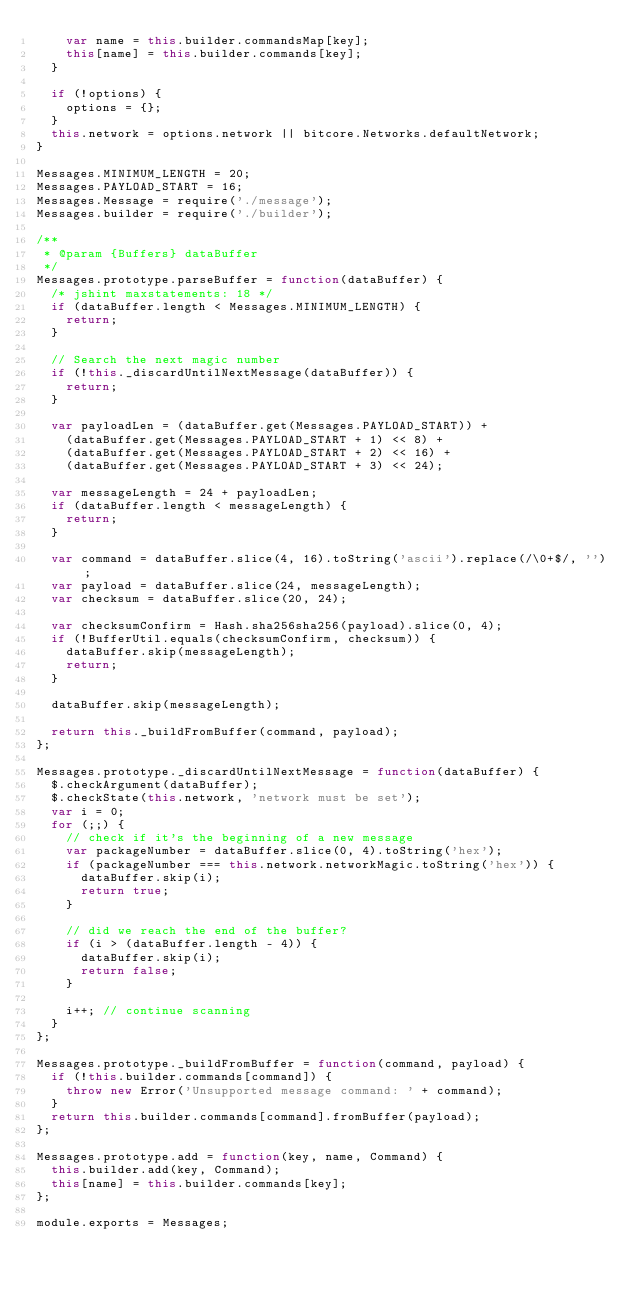Convert code to text. <code><loc_0><loc_0><loc_500><loc_500><_JavaScript_>    var name = this.builder.commandsMap[key];
    this[name] = this.builder.commands[key];
  }

  if (!options) {
    options = {};
  }
  this.network = options.network || bitcore.Networks.defaultNetwork;
}

Messages.MINIMUM_LENGTH = 20;
Messages.PAYLOAD_START = 16;
Messages.Message = require('./message');
Messages.builder = require('./builder');

/**
 * @param {Buffers} dataBuffer
 */
Messages.prototype.parseBuffer = function(dataBuffer) {
  /* jshint maxstatements: 18 */
  if (dataBuffer.length < Messages.MINIMUM_LENGTH) {
    return;
  }

  // Search the next magic number
  if (!this._discardUntilNextMessage(dataBuffer)) {
    return;
  }

  var payloadLen = (dataBuffer.get(Messages.PAYLOAD_START)) +
    (dataBuffer.get(Messages.PAYLOAD_START + 1) << 8) +
    (dataBuffer.get(Messages.PAYLOAD_START + 2) << 16) +
    (dataBuffer.get(Messages.PAYLOAD_START + 3) << 24);

  var messageLength = 24 + payloadLen;
  if (dataBuffer.length < messageLength) {
    return;
  }

  var command = dataBuffer.slice(4, 16).toString('ascii').replace(/\0+$/, '');
  var payload = dataBuffer.slice(24, messageLength);
  var checksum = dataBuffer.slice(20, 24);

  var checksumConfirm = Hash.sha256sha256(payload).slice(0, 4);
  if (!BufferUtil.equals(checksumConfirm, checksum)) {
    dataBuffer.skip(messageLength);
    return;
  }

  dataBuffer.skip(messageLength);

  return this._buildFromBuffer(command, payload);
};

Messages.prototype._discardUntilNextMessage = function(dataBuffer) {
  $.checkArgument(dataBuffer);
  $.checkState(this.network, 'network must be set');
  var i = 0;
  for (;;) {
    // check if it's the beginning of a new message
    var packageNumber = dataBuffer.slice(0, 4).toString('hex');
    if (packageNumber === this.network.networkMagic.toString('hex')) {
      dataBuffer.skip(i);
      return true;
    }

    // did we reach the end of the buffer?
    if (i > (dataBuffer.length - 4)) {
      dataBuffer.skip(i);
      return false;
    }

    i++; // continue scanning
  }
};

Messages.prototype._buildFromBuffer = function(command, payload) {
  if (!this.builder.commands[command]) {
    throw new Error('Unsupported message command: ' + command);
  }
  return this.builder.commands[command].fromBuffer(payload);
};

Messages.prototype.add = function(key, name, Command) {
  this.builder.add(key, Command);
  this[name] = this.builder.commands[key];
};

module.exports = Messages;
</code> 